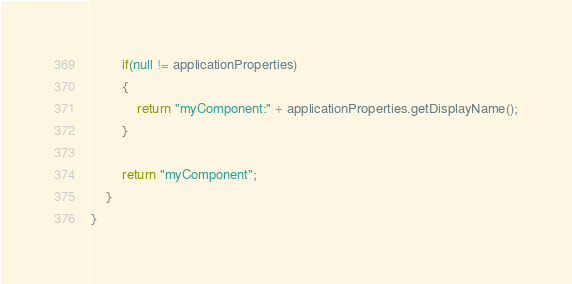Convert code to text. <code><loc_0><loc_0><loc_500><loc_500><_Java_>        if(null != applicationProperties)
        {
            return "myComponent:" + applicationProperties.getDisplayName();
        }
        
        return "myComponent";
    }
}</code> 